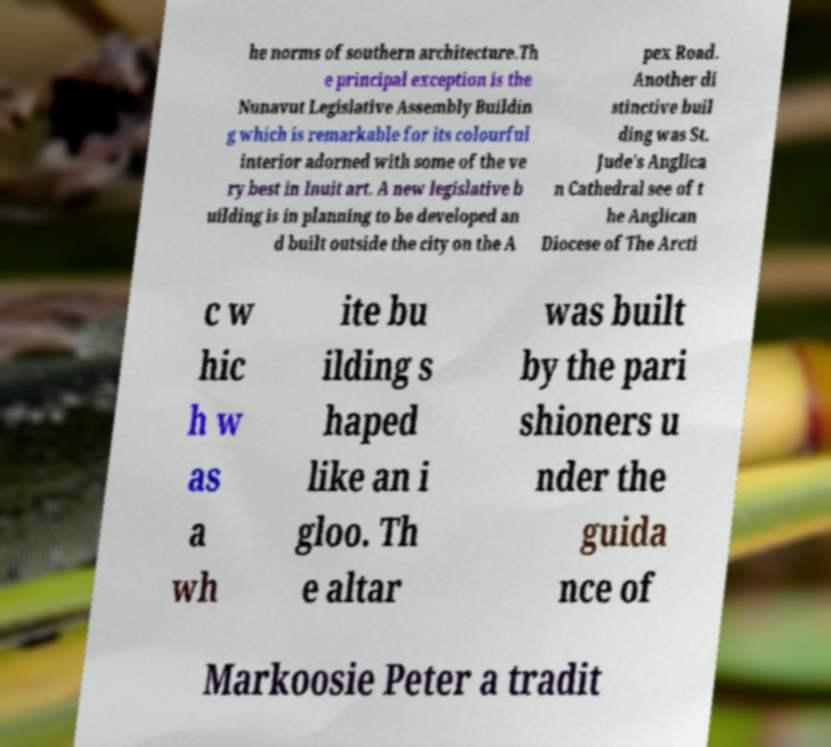Could you extract and type out the text from this image? he norms of southern architecture.Th e principal exception is the Nunavut Legislative Assembly Buildin g which is remarkable for its colourful interior adorned with some of the ve ry best in Inuit art. A new legislative b uilding is in planning to be developed an d built outside the city on the A pex Road. Another di stinctive buil ding was St. Jude's Anglica n Cathedral see of t he Anglican Diocese of The Arcti c w hic h w as a wh ite bu ilding s haped like an i gloo. Th e altar was built by the pari shioners u nder the guida nce of Markoosie Peter a tradit 